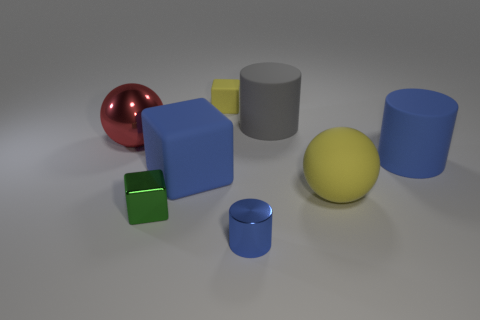Subtract all big rubber cylinders. How many cylinders are left? 1 Add 2 big balls. How many objects exist? 10 Subtract 1 cylinders. How many cylinders are left? 2 Subtract all yellow blocks. How many blocks are left? 2 Subtract 0 cyan blocks. How many objects are left? 8 Subtract all spheres. How many objects are left? 6 Subtract all cyan cylinders. Subtract all red spheres. How many cylinders are left? 3 Subtract all red cylinders. How many cyan blocks are left? 0 Subtract all big green metallic cylinders. Subtract all big gray matte cylinders. How many objects are left? 7 Add 5 green metallic blocks. How many green metallic blocks are left? 6 